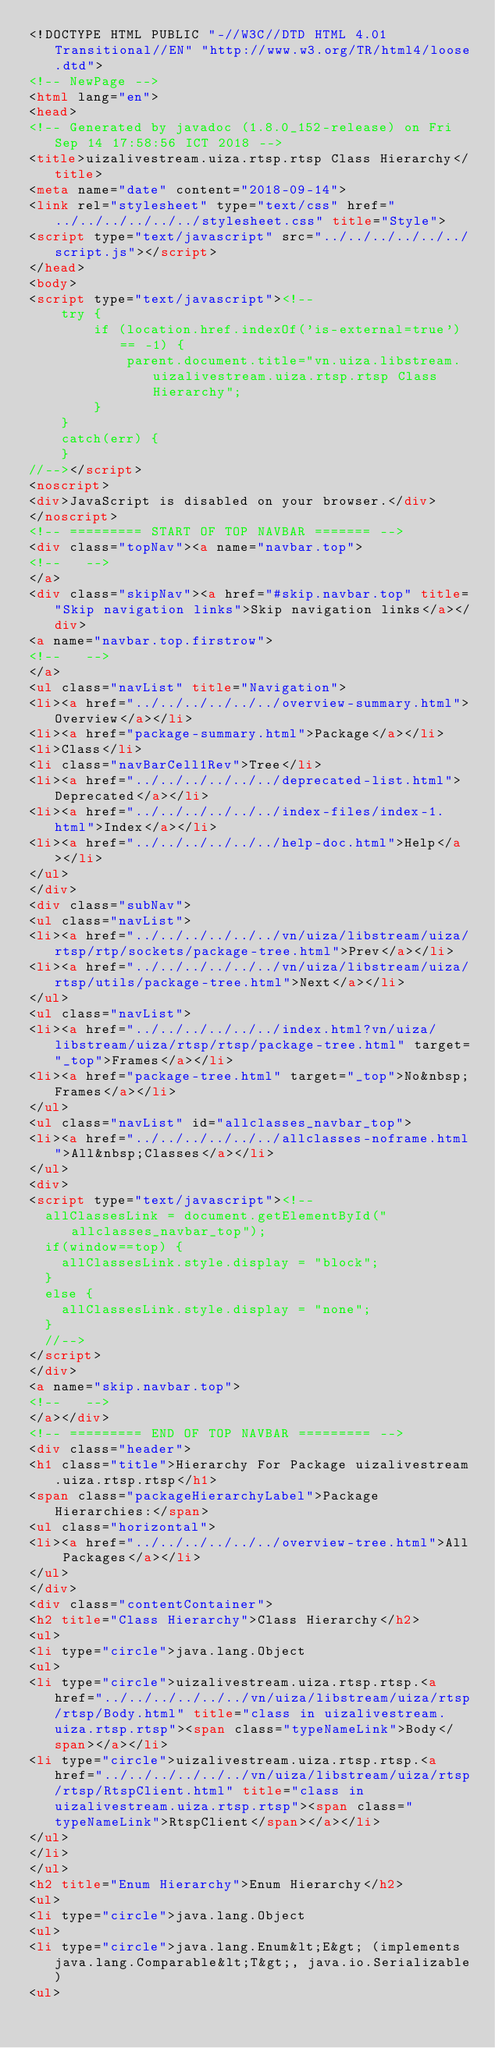<code> <loc_0><loc_0><loc_500><loc_500><_HTML_><!DOCTYPE HTML PUBLIC "-//W3C//DTD HTML 4.01 Transitional//EN" "http://www.w3.org/TR/html4/loose.dtd">
<!-- NewPage -->
<html lang="en">
<head>
<!-- Generated by javadoc (1.8.0_152-release) on Fri Sep 14 17:58:56 ICT 2018 -->
<title>uizalivestream.uiza.rtsp.rtsp Class Hierarchy</title>
<meta name="date" content="2018-09-14">
<link rel="stylesheet" type="text/css" href="../../../../../../stylesheet.css" title="Style">
<script type="text/javascript" src="../../../../../../script.js"></script>
</head>
<body>
<script type="text/javascript"><!--
    try {
        if (location.href.indexOf('is-external=true') == -1) {
            parent.document.title="vn.uiza.libstream.uizalivestream.uiza.rtsp.rtsp Class Hierarchy";
        }
    }
    catch(err) {
    }
//--></script>
<noscript>
<div>JavaScript is disabled on your browser.</div>
</noscript>
<!-- ========= START OF TOP NAVBAR ======= -->
<div class="topNav"><a name="navbar.top">
<!--   -->
</a>
<div class="skipNav"><a href="#skip.navbar.top" title="Skip navigation links">Skip navigation links</a></div>
<a name="navbar.top.firstrow">
<!--   -->
</a>
<ul class="navList" title="Navigation">
<li><a href="../../../../../../overview-summary.html">Overview</a></li>
<li><a href="package-summary.html">Package</a></li>
<li>Class</li>
<li class="navBarCell1Rev">Tree</li>
<li><a href="../../../../../../deprecated-list.html">Deprecated</a></li>
<li><a href="../../../../../../index-files/index-1.html">Index</a></li>
<li><a href="../../../../../../help-doc.html">Help</a></li>
</ul>
</div>
<div class="subNav">
<ul class="navList">
<li><a href="../../../../../../vn/uiza/libstream/uiza/rtsp/rtp/sockets/package-tree.html">Prev</a></li>
<li><a href="../../../../../../vn/uiza/libstream/uiza/rtsp/utils/package-tree.html">Next</a></li>
</ul>
<ul class="navList">
<li><a href="../../../../../../index.html?vn/uiza/libstream/uiza/rtsp/rtsp/package-tree.html" target="_top">Frames</a></li>
<li><a href="package-tree.html" target="_top">No&nbsp;Frames</a></li>
</ul>
<ul class="navList" id="allclasses_navbar_top">
<li><a href="../../../../../../allclasses-noframe.html">All&nbsp;Classes</a></li>
</ul>
<div>
<script type="text/javascript"><!--
  allClassesLink = document.getElementById("allclasses_navbar_top");
  if(window==top) {
    allClassesLink.style.display = "block";
  }
  else {
    allClassesLink.style.display = "none";
  }
  //-->
</script>
</div>
<a name="skip.navbar.top">
<!--   -->
</a></div>
<!-- ========= END OF TOP NAVBAR ========= -->
<div class="header">
<h1 class="title">Hierarchy For Package uizalivestream.uiza.rtsp.rtsp</h1>
<span class="packageHierarchyLabel">Package Hierarchies:</span>
<ul class="horizontal">
<li><a href="../../../../../../overview-tree.html">All Packages</a></li>
</ul>
</div>
<div class="contentContainer">
<h2 title="Class Hierarchy">Class Hierarchy</h2>
<ul>
<li type="circle">java.lang.Object
<ul>
<li type="circle">uizalivestream.uiza.rtsp.rtsp.<a href="../../../../../../vn/uiza/libstream/uiza/rtsp/rtsp/Body.html" title="class in uizalivestream.uiza.rtsp.rtsp"><span class="typeNameLink">Body</span></a></li>
<li type="circle">uizalivestream.uiza.rtsp.rtsp.<a href="../../../../../../vn/uiza/libstream/uiza/rtsp/rtsp/RtspClient.html" title="class in uizalivestream.uiza.rtsp.rtsp"><span class="typeNameLink">RtspClient</span></a></li>
</ul>
</li>
</ul>
<h2 title="Enum Hierarchy">Enum Hierarchy</h2>
<ul>
<li type="circle">java.lang.Object
<ul>
<li type="circle">java.lang.Enum&lt;E&gt; (implements java.lang.Comparable&lt;T&gt;, java.io.Serializable)
<ul></code> 